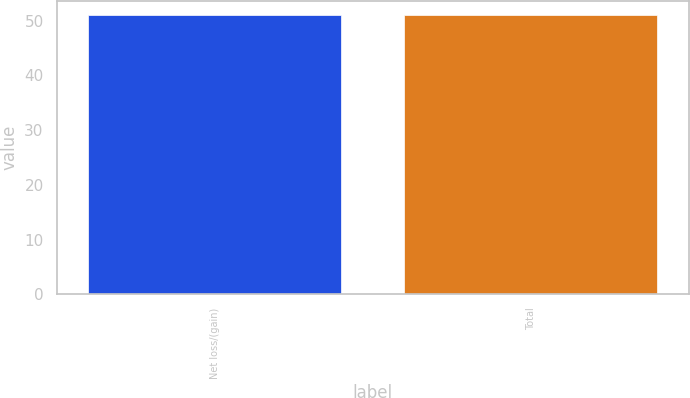Convert chart. <chart><loc_0><loc_0><loc_500><loc_500><bar_chart><fcel>Net loss/(gain)<fcel>Total<nl><fcel>51<fcel>51.1<nl></chart> 